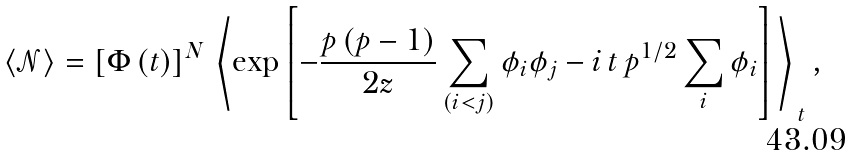Convert formula to latex. <formula><loc_0><loc_0><loc_500><loc_500>\langle \mathcal { N } \rangle = \left [ \Phi \left ( t \right ) \right ] ^ { N } \, \left \langle \exp \left [ - \frac { p \left ( p - 1 \right ) } { 2 z } \sum _ { \left ( i < j \right ) } \phi _ { i } \phi _ { j } - i \, t \, p ^ { 1 / 2 } \sum _ { i } \phi _ { i } \right ] \, \right \rangle _ { \, t } ,</formula> 